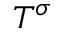Convert formula to latex. <formula><loc_0><loc_0><loc_500><loc_500>T ^ { \sigma }</formula> 